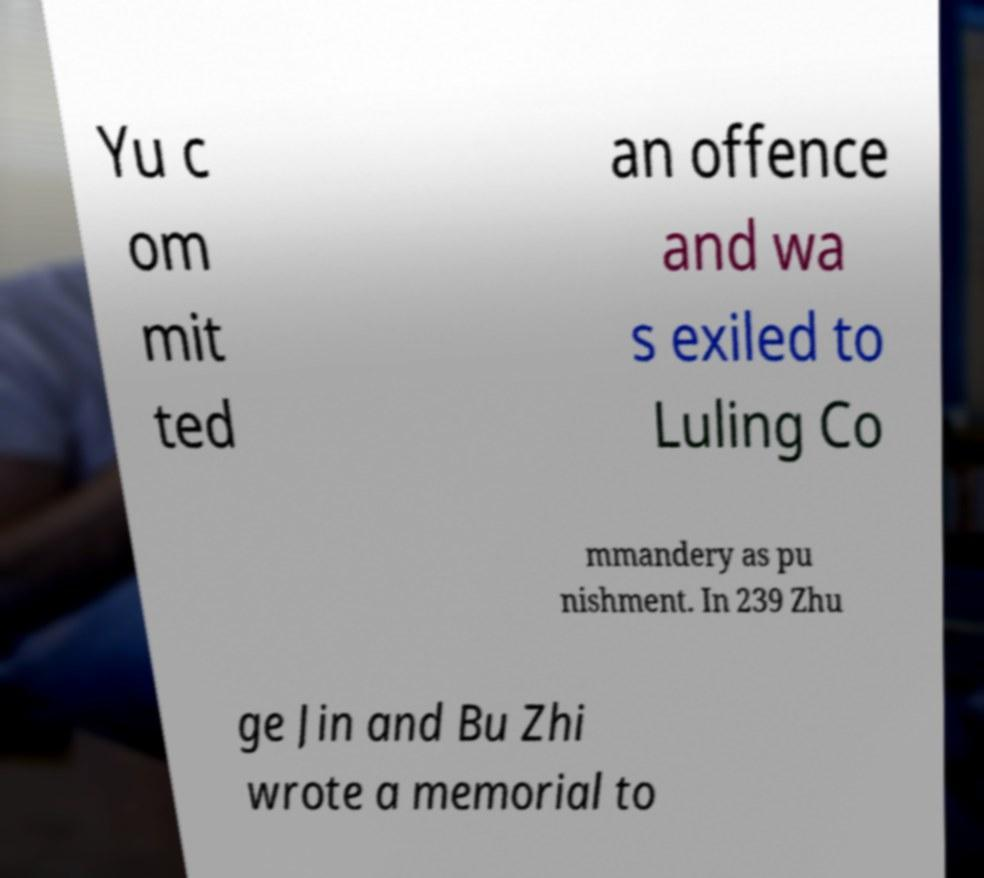Can you accurately transcribe the text from the provided image for me? Yu c om mit ted an offence and wa s exiled to Luling Co mmandery as pu nishment. In 239 Zhu ge Jin and Bu Zhi wrote a memorial to 